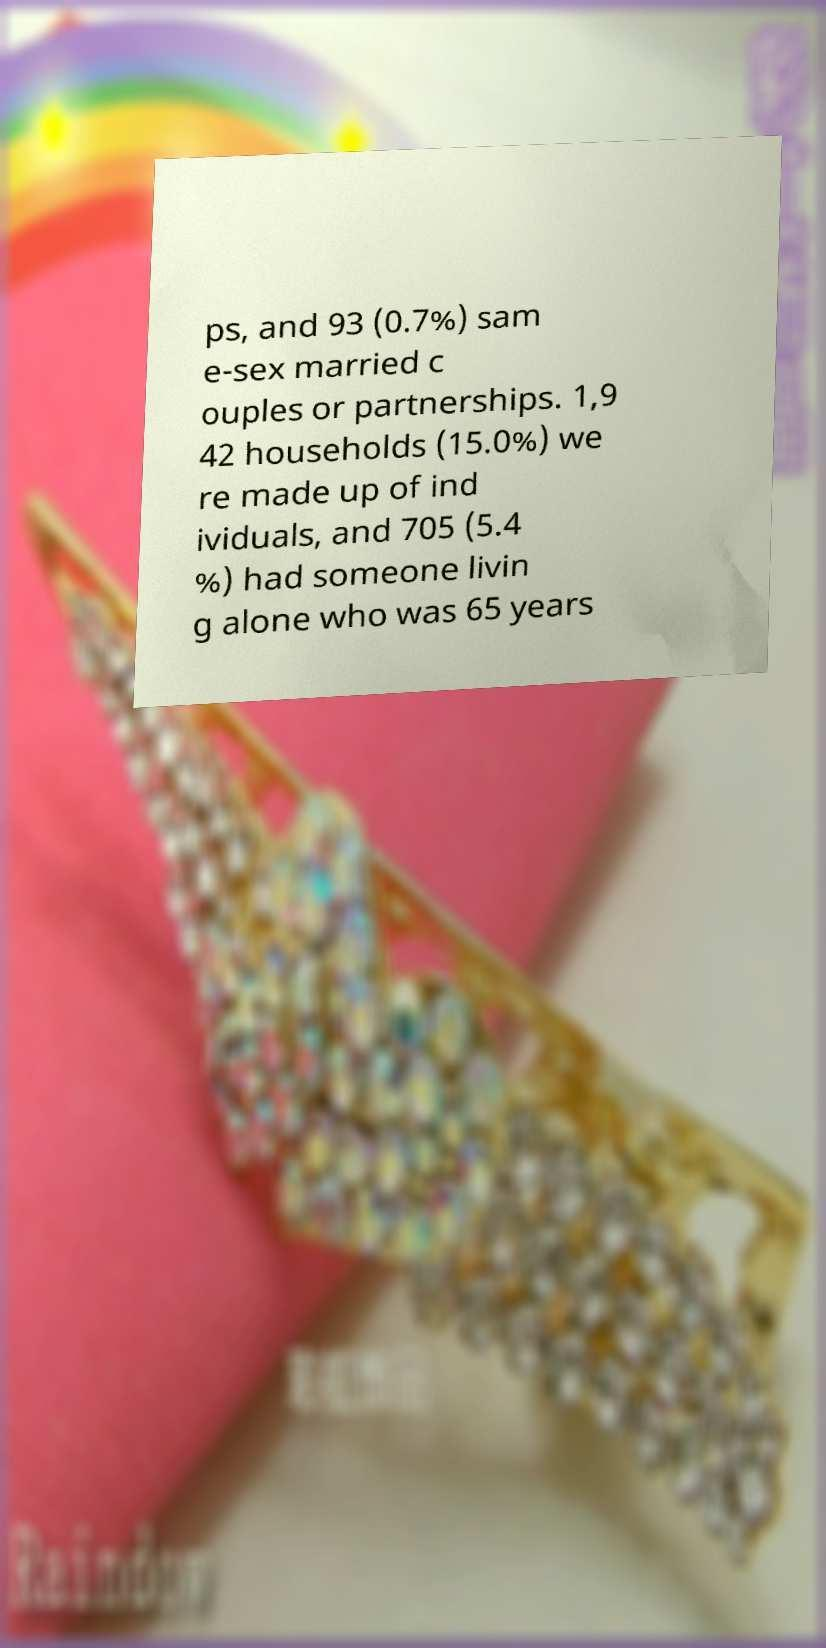Could you assist in decoding the text presented in this image and type it out clearly? ps, and 93 (0.7%) sam e-sex married c ouples or partnerships. 1,9 42 households (15.0%) we re made up of ind ividuals, and 705 (5.4 %) had someone livin g alone who was 65 years 